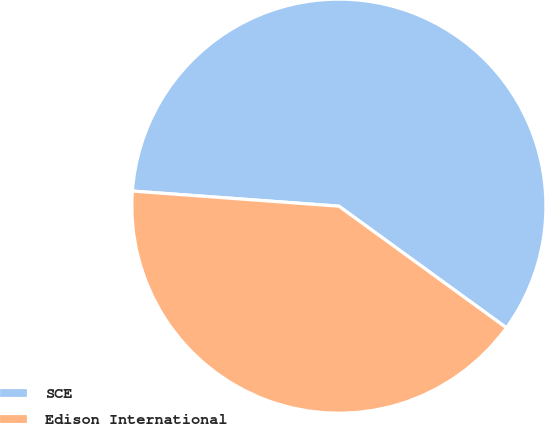<chart> <loc_0><loc_0><loc_500><loc_500><pie_chart><fcel>SCE<fcel>Edison International<nl><fcel>58.83%<fcel>41.17%<nl></chart> 